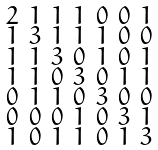Convert formula to latex. <formula><loc_0><loc_0><loc_500><loc_500>\begin{smallmatrix} 2 & 1 & 1 & 1 & 0 & 0 & 1 \\ 1 & 3 & 1 & 1 & 1 & 0 & 0 \\ 1 & 1 & 3 & 0 & 1 & 0 & 1 \\ 1 & 1 & 0 & 3 & 0 & 1 & 1 \\ 0 & 1 & 1 & 0 & 3 & 0 & 0 \\ 0 & 0 & 0 & 1 & 0 & 3 & 1 \\ 1 & 0 & 1 & 1 & 0 & 1 & 3 \end{smallmatrix}</formula> 